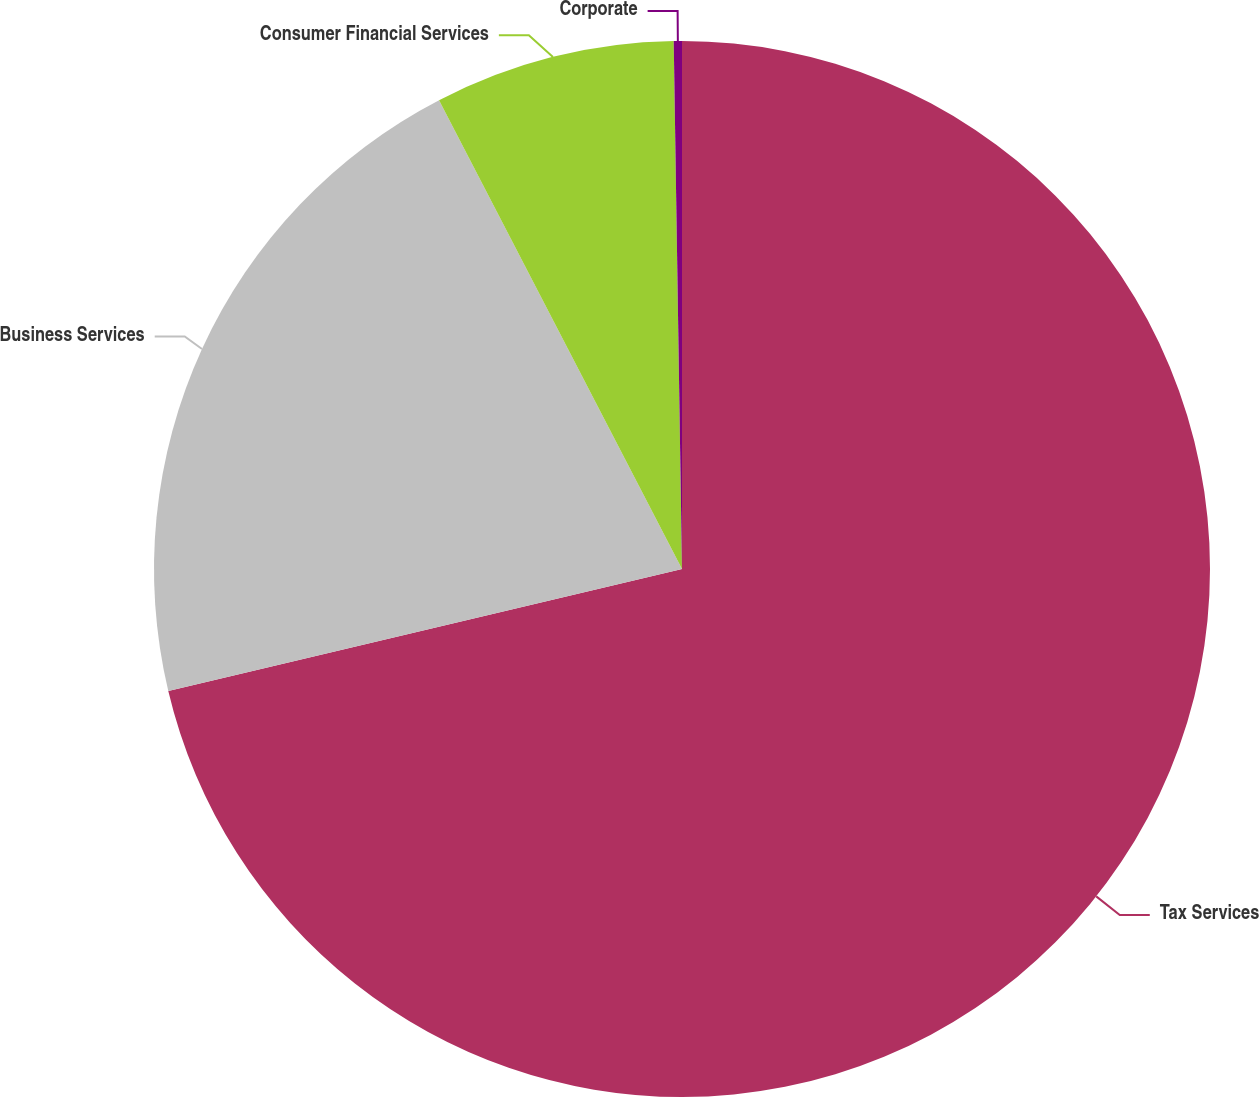<chart> <loc_0><loc_0><loc_500><loc_500><pie_chart><fcel>Tax Services<fcel>Business Services<fcel>Consumer Financial Services<fcel>Corporate<nl><fcel>71.29%<fcel>21.1%<fcel>7.36%<fcel>0.25%<nl></chart> 